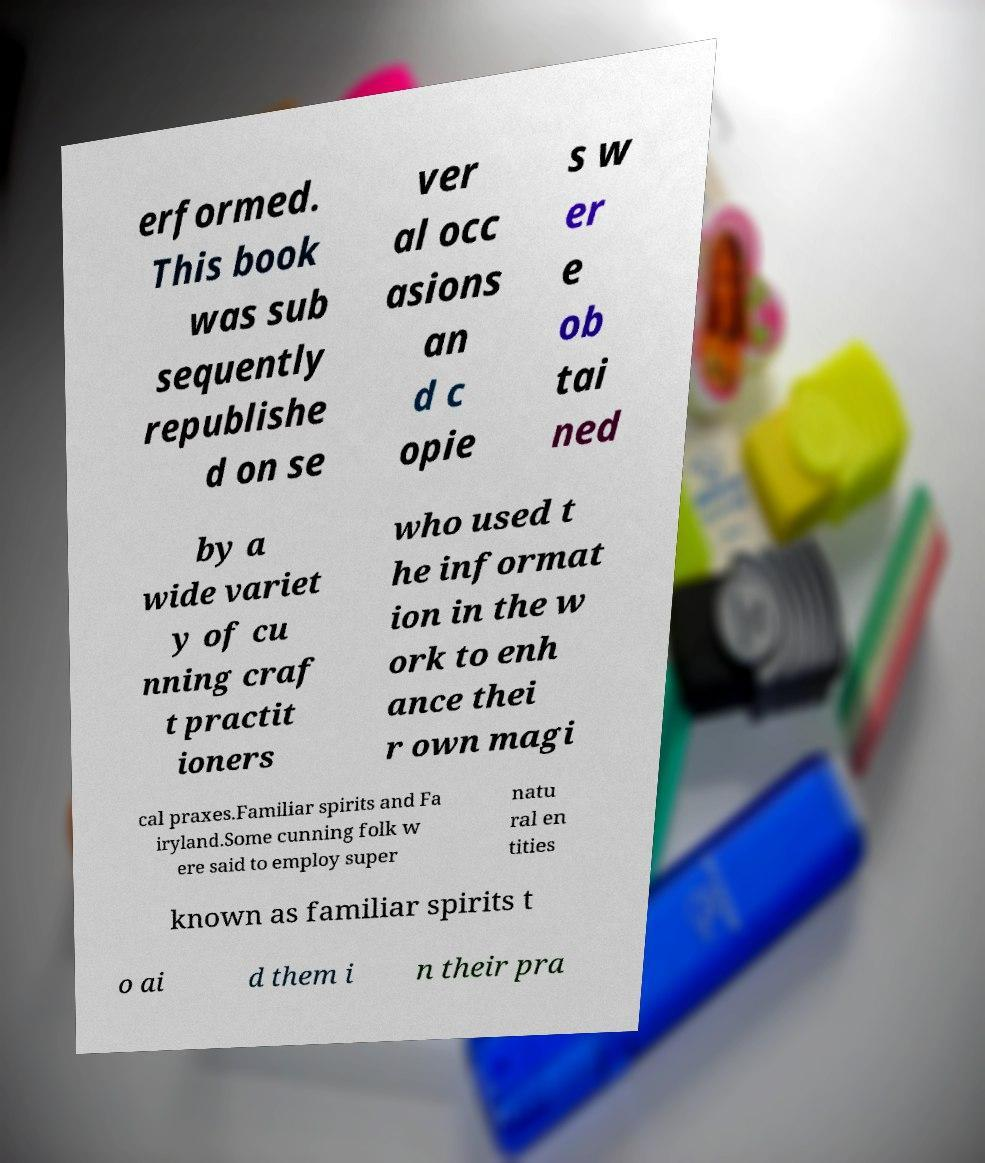Can you read and provide the text displayed in the image?This photo seems to have some interesting text. Can you extract and type it out for me? erformed. This book was sub sequently republishe d on se ver al occ asions an d c opie s w er e ob tai ned by a wide variet y of cu nning craf t practit ioners who used t he informat ion in the w ork to enh ance thei r own magi cal praxes.Familiar spirits and Fa iryland.Some cunning folk w ere said to employ super natu ral en tities known as familiar spirits t o ai d them i n their pra 